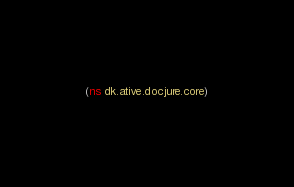Convert code to text. <code><loc_0><loc_0><loc_500><loc_500><_Clojure_>(ns dk.ative.docjure.core)
</code> 